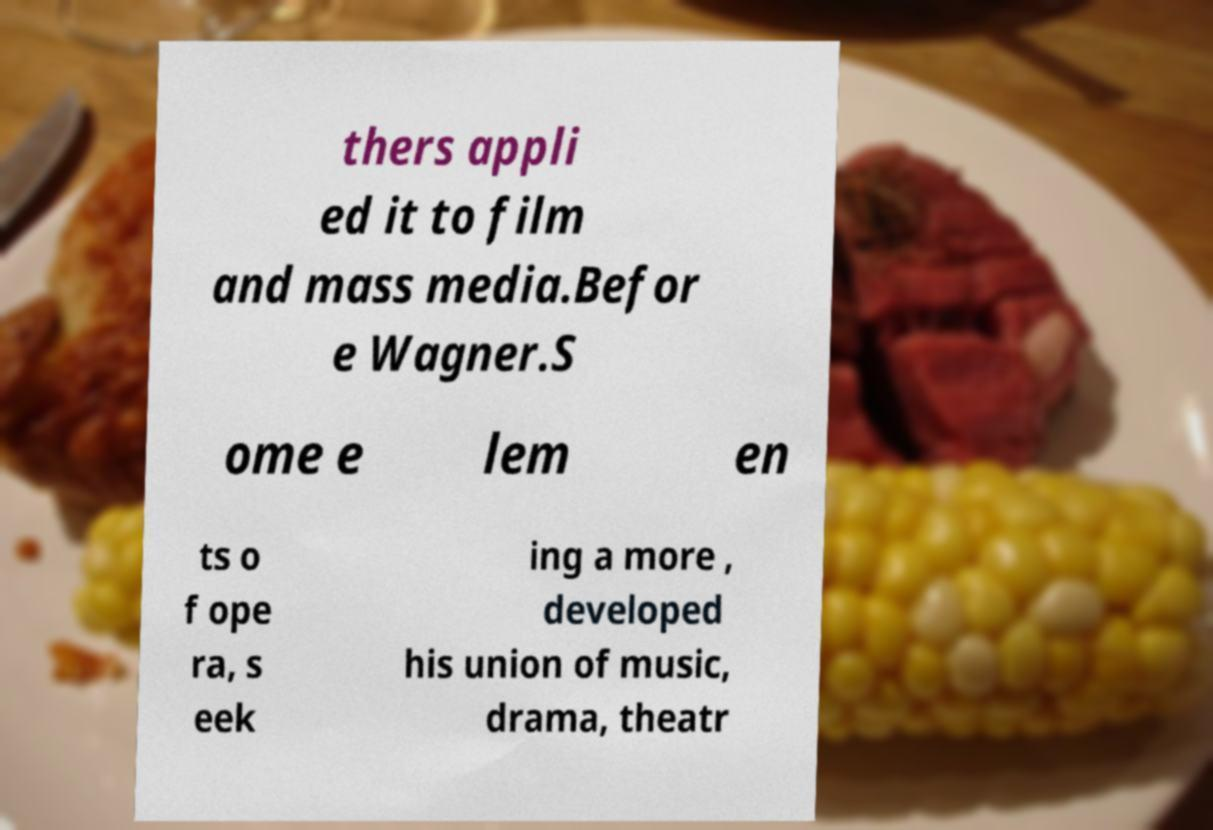Could you assist in decoding the text presented in this image and type it out clearly? thers appli ed it to film and mass media.Befor e Wagner.S ome e lem en ts o f ope ra, s eek ing a more , developed his union of music, drama, theatr 